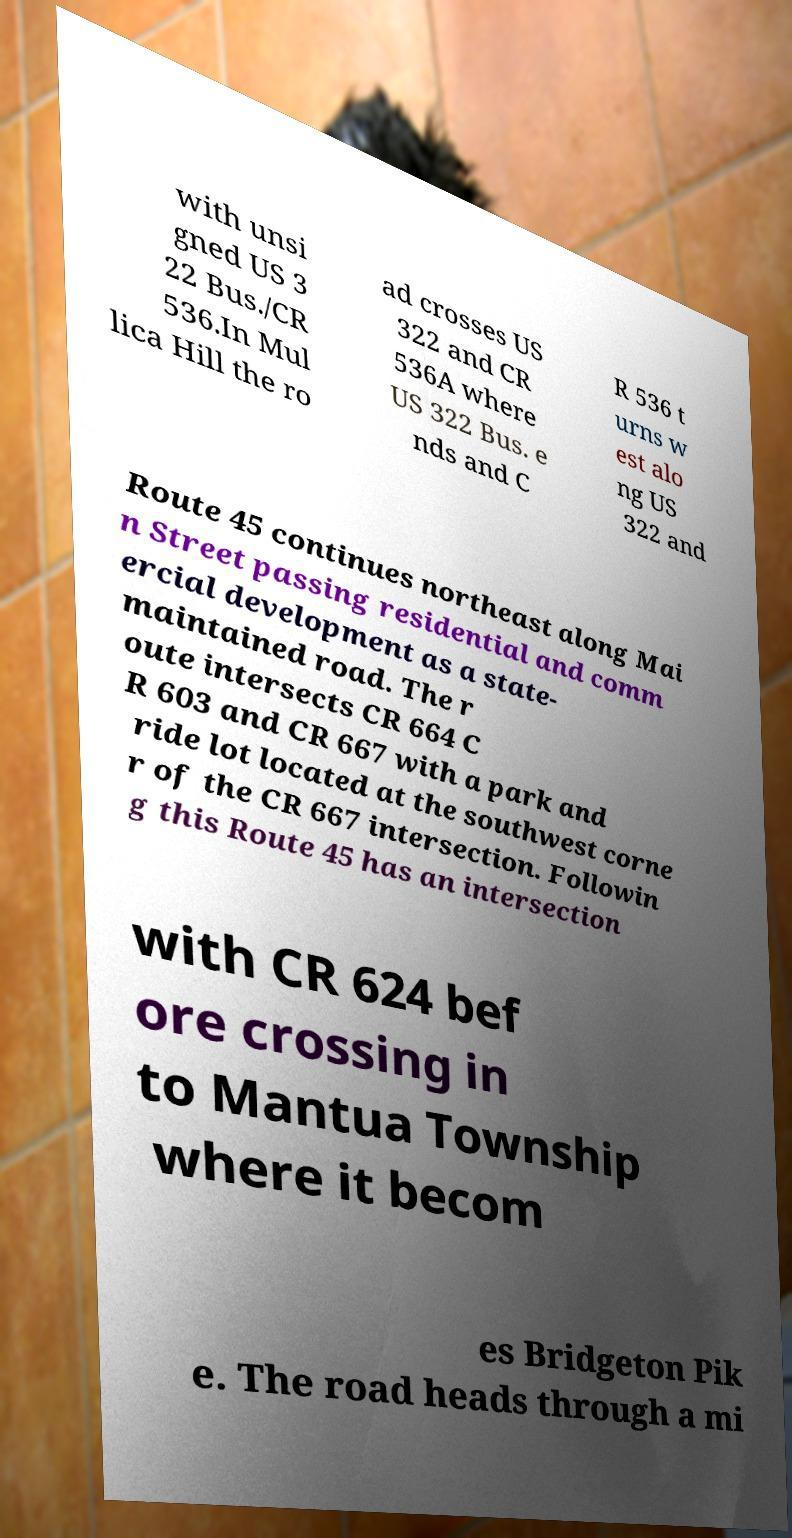Could you assist in decoding the text presented in this image and type it out clearly? with unsi gned US 3 22 Bus./CR 536.In Mul lica Hill the ro ad crosses US 322 and CR 536A where US 322 Bus. e nds and C R 536 t urns w est alo ng US 322 and Route 45 continues northeast along Mai n Street passing residential and comm ercial development as a state- maintained road. The r oute intersects CR 664 C R 603 and CR 667 with a park and ride lot located at the southwest corne r of the CR 667 intersection. Followin g this Route 45 has an intersection with CR 624 bef ore crossing in to Mantua Township where it becom es Bridgeton Pik e. The road heads through a mi 